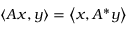Convert formula to latex. <formula><loc_0><loc_0><loc_500><loc_500>\langle A x , y \rangle = \left \langle x , A ^ { * } y \right \rangle</formula> 